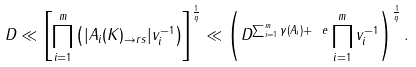<formula> <loc_0><loc_0><loc_500><loc_500>D \ll \left [ \prod _ { i = 1 } ^ { m } \left ( | A _ { i } ( K ) _ { \to r s } | v _ { i } ^ { - 1 } \right ) \right ] ^ { \frac { 1 } { q } } \ll \left ( D ^ { \sum _ { i = 1 } ^ { m } \gamma ( A _ { i } ) + \ e } \prod _ { i = 1 } ^ { m } v _ { i } ^ { - 1 } \right ) ^ { \frac { 1 } { q } } .</formula> 